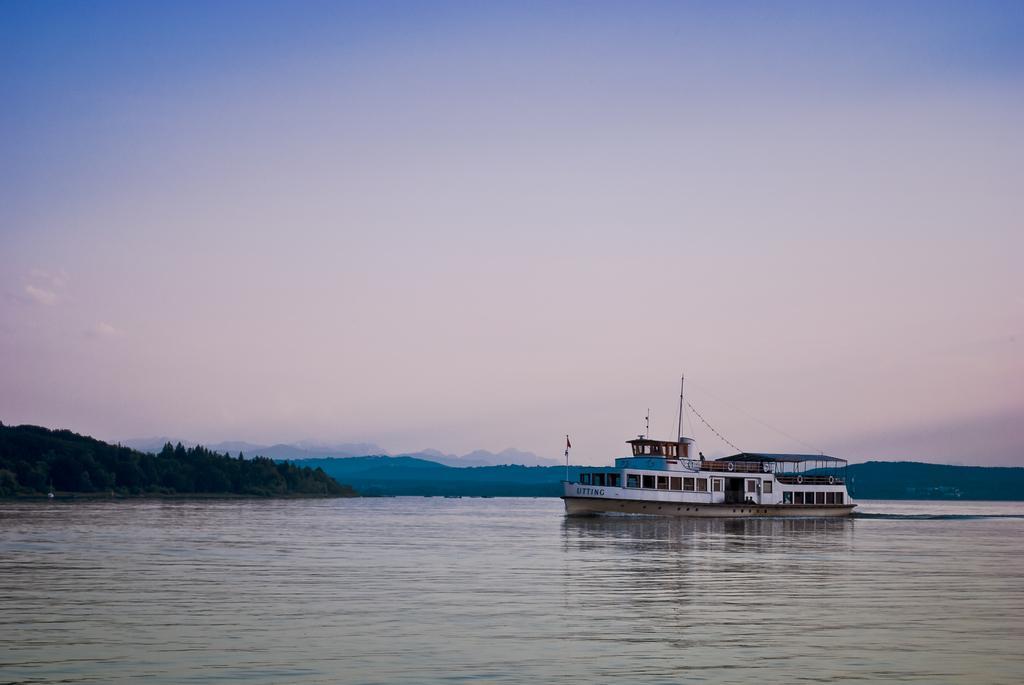How would you summarize this image in a sentence or two? This picture consists of a ship on the lake , in the middle there are some trees, the hill, at the top there is the sky. 